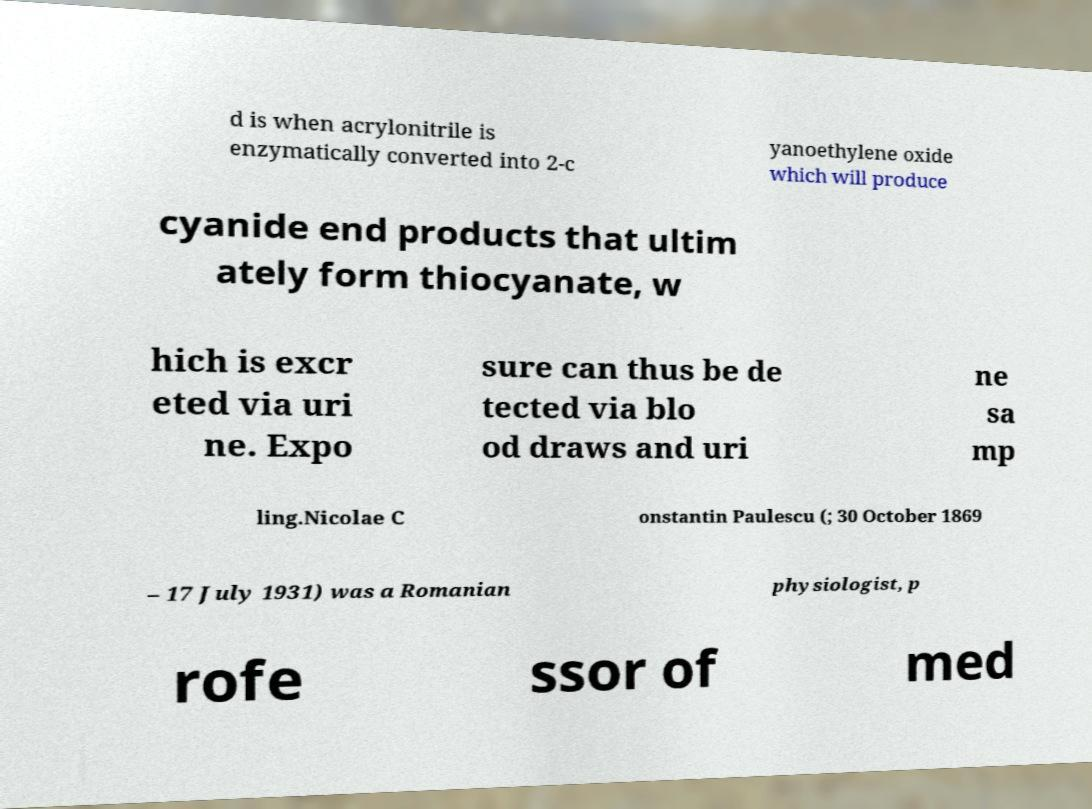Could you assist in decoding the text presented in this image and type it out clearly? d is when acrylonitrile is enzymatically converted into 2-c yanoethylene oxide which will produce cyanide end products that ultim ately form thiocyanate, w hich is excr eted via uri ne. Expo sure can thus be de tected via blo od draws and uri ne sa mp ling.Nicolae C onstantin Paulescu (; 30 October 1869 – 17 July 1931) was a Romanian physiologist, p rofe ssor of med 